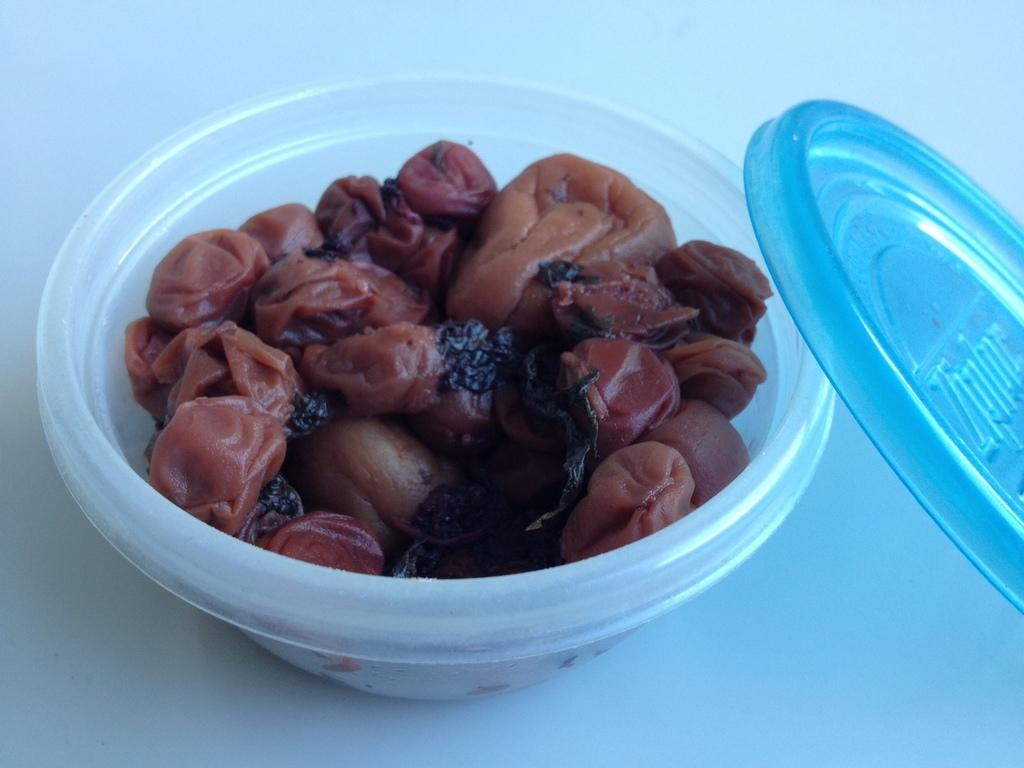What is the color of the surface in the image? The surface in the image is white. What object is placed on the surface? There is a plastic bowl on the surface. What color is the lid of the bowl? The lid of the bowl is blue. What can be inferred about the food item in the bowl based on its color? The food item in the bowl is brown and black in color, which might suggest it is a type of meat or a dish with a dark sauce. What is the aftermath of the lumber in the image? There is no lumber present in the image, so it is not possible to discuss its aftermath. 